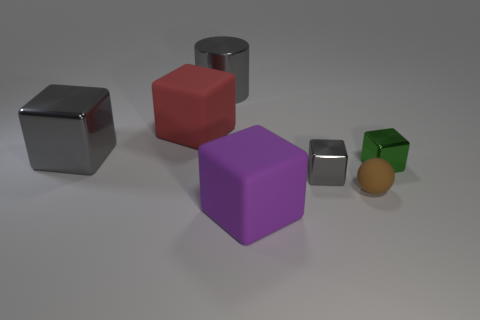What number of spheres have the same material as the large red thing?
Give a very brief answer. 1. What number of other cubes are the same size as the purple block?
Your answer should be very brief. 2. What is the tiny cube to the right of the metallic block in front of the metallic thing right of the tiny brown thing made of?
Keep it short and to the point. Metal. What number of things are matte things or green things?
Your response must be concise. 4. Is there any other thing that has the same material as the brown ball?
Keep it short and to the point. Yes. What is the shape of the tiny brown matte thing?
Offer a very short reply. Sphere. The matte thing right of the gray metal cube that is in front of the green thing is what shape?
Give a very brief answer. Sphere. Do the gray cube behind the tiny gray thing and the cylinder have the same material?
Provide a succinct answer. Yes. What number of cyan objects are either small shiny objects or small rubber balls?
Your response must be concise. 0. Is there a matte ball of the same color as the large metal block?
Your answer should be very brief. No. 